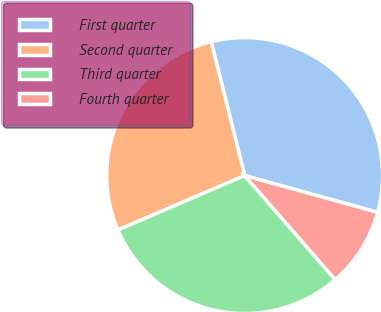<chart> <loc_0><loc_0><loc_500><loc_500><pie_chart><fcel>First quarter<fcel>Second quarter<fcel>Third quarter<fcel>Fourth quarter<nl><fcel>33.2%<fcel>27.55%<fcel>29.94%<fcel>9.31%<nl></chart> 